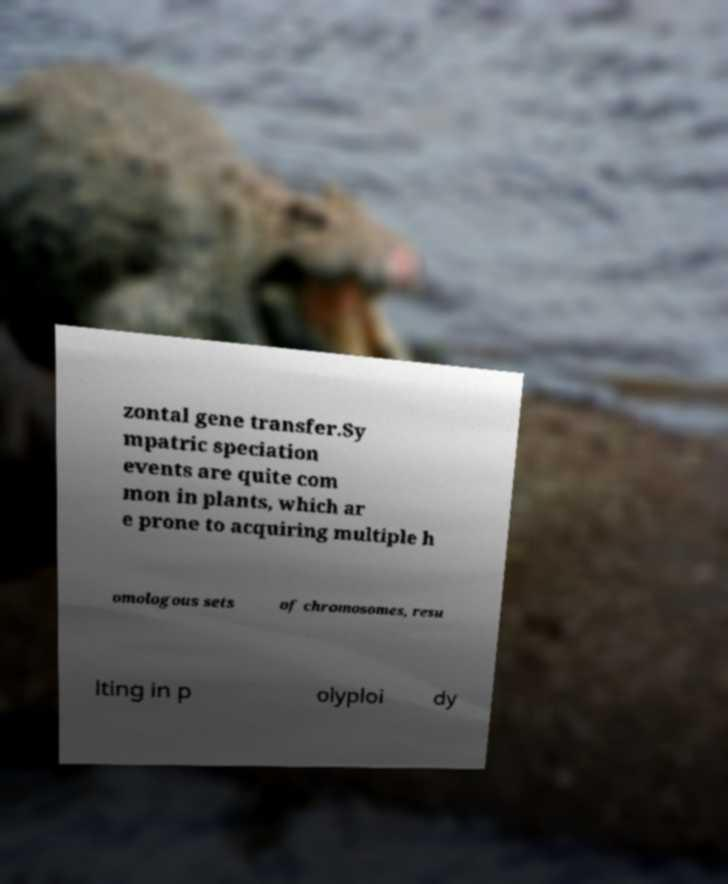Could you extract and type out the text from this image? zontal gene transfer.Sy mpatric speciation events are quite com mon in plants, which ar e prone to acquiring multiple h omologous sets of chromosomes, resu lting in p olyploi dy 